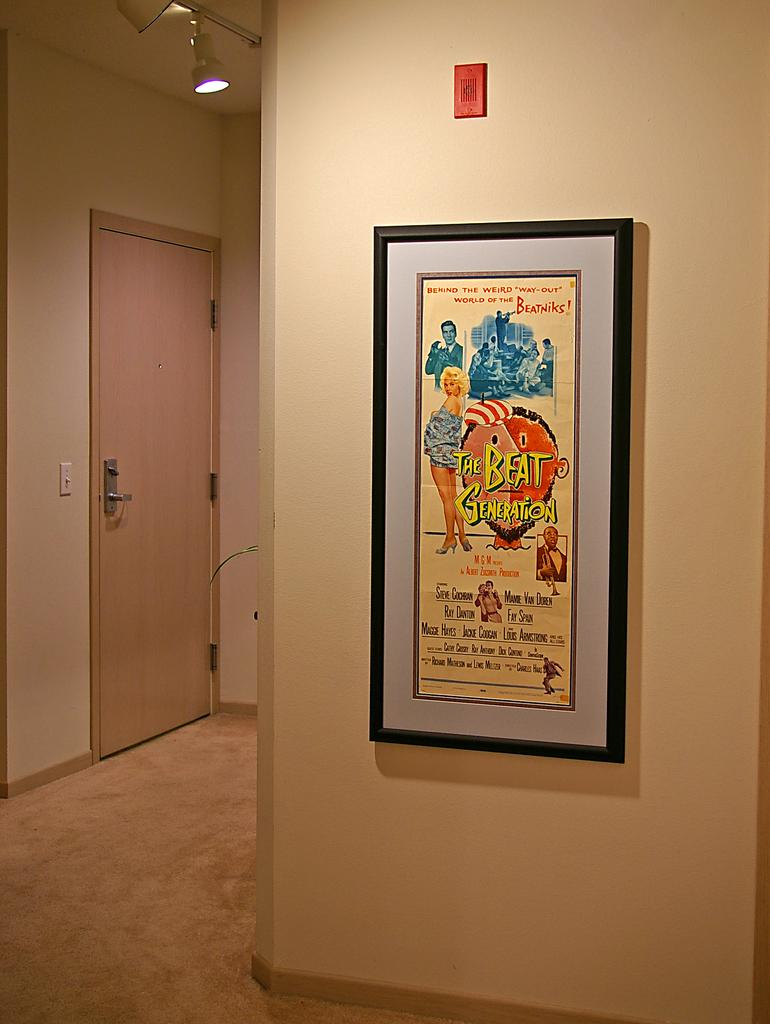<image>
Create a compact narrative representing the image presented. A framed poster that says, "The Beat Generation" is hanging on an apartment wall. 